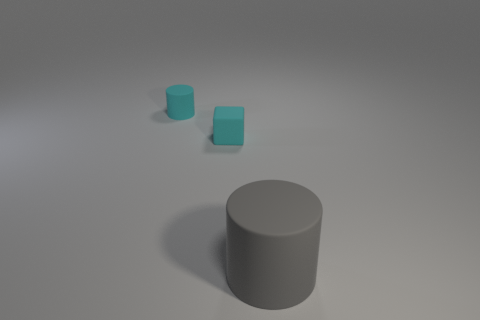What is the shape of the large gray rubber thing?
Keep it short and to the point. Cylinder. What is the material of the other thing that is the same shape as the big thing?
Your answer should be compact. Rubber. How many objects have the same size as the cube?
Ensure brevity in your answer.  1. Are there any cyan blocks behind the small matte object that is to the right of the small cylinder?
Give a very brief answer. No. What number of brown objects are either matte objects or tiny rubber cylinders?
Provide a short and direct response. 0. What color is the small rubber block?
Your response must be concise. Cyan. There is a gray cylinder that is the same material as the block; what is its size?
Provide a succinct answer. Large. What number of other large things have the same shape as the gray thing?
Ensure brevity in your answer.  0. Is there any other thing that is the same size as the cube?
Make the answer very short. Yes. What is the size of the cyan rubber object that is to the right of the matte cylinder that is to the left of the gray matte cylinder?
Provide a succinct answer. Small. 